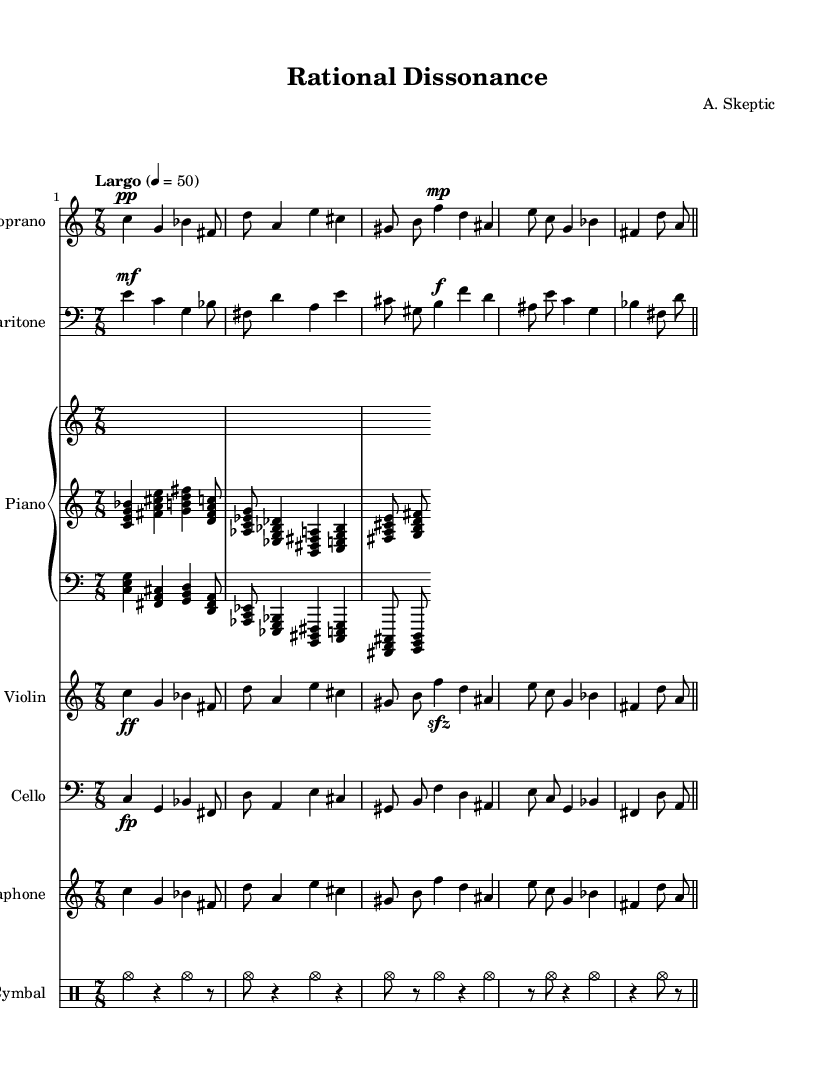What is the time signature of this music? The time signature is 7/8, as indicated at the beginning of the score. This means there are seven beats in each measure, and the eighth note gets one beat.
Answer: 7/8 What is the tempo marking for this piece? The tempo marking is "Largo," which suggests a slow tempo. It is specified in beats per minute as 4 equals 50.
Answer: Largo Which musical instrument is indicated to have a bass clef? The baritone and cello are both notated using the bass clef in their respective staves. This suggests they play in a lower register than the soprano, which is in treble clef.
Answer: Baritone, Cello What dynamic marking is indicated for the final soprano note? The final note in the soprano line is marked with a "pp" dynamic, which stands for "pianissimo," indicating it should be played very softly.
Answer: pp How many instruments are featured in this score? There are six instruments featured in the score: Soprano, Baritone, Piano, Violin, Cello, and Vibraphone. Additionally, there is a percussion part for Cymbal.
Answer: Six What thematic concept is reflected in the lyrics of the opera? The lyrics discuss themes of atheism and reason, suggesting that the opera explores how these ideas reshape thoughts and societal paradigms, thus connecting to modern society.
Answer: Atheism What is the texture of the piece indicated by the use of multiple instruments? The piece demonstrates a rich texture, likely polyphonic, as it utilizes a variety of instruments including vocal lines that intertwine, creating a complex soundscape typical in operatic compositions.
Answer: Polyphonic 